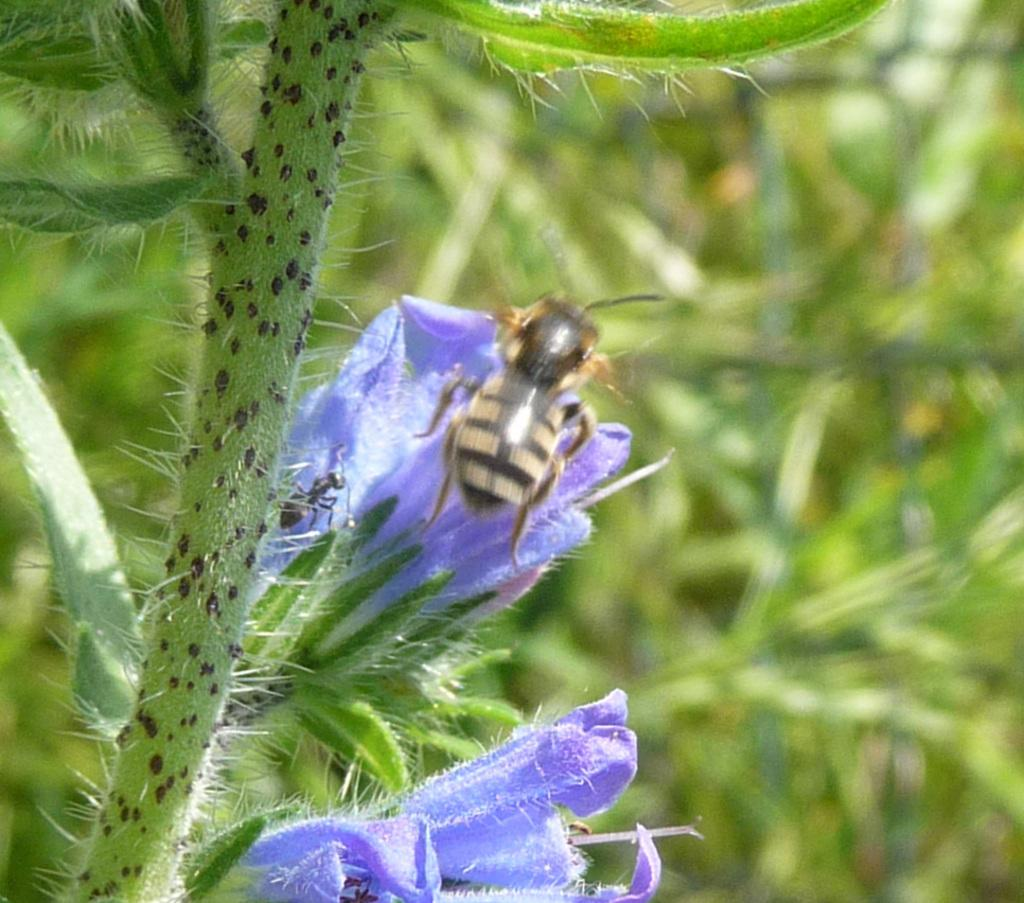What types of living organisms can be seen in the image? There are multiple plants in the image. Can you describe any specific flowers in the image? Yes, there are two purple flowers in the image. What else can be seen on the flowers? An insect is present on the flowers. How would you describe the background of the image? The background of the image is blurry. What type of veil can be seen in the image? There is no veil present in the image. Can you tell me how many members are on the team in the image? There is no team present in the image. 